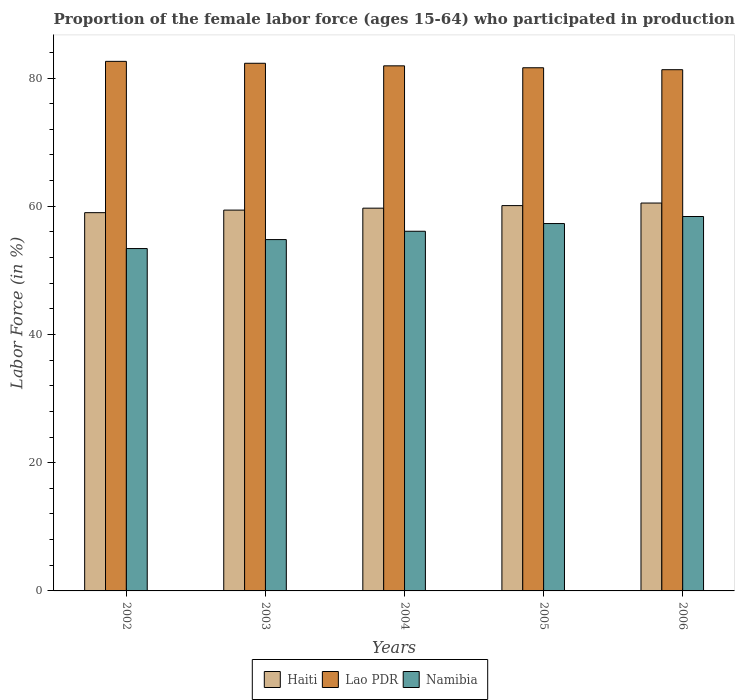How many groups of bars are there?
Offer a very short reply. 5. How many bars are there on the 5th tick from the right?
Give a very brief answer. 3. What is the label of the 1st group of bars from the left?
Give a very brief answer. 2002. What is the proportion of the female labor force who participated in production in Lao PDR in 2002?
Make the answer very short. 82.6. Across all years, what is the maximum proportion of the female labor force who participated in production in Namibia?
Give a very brief answer. 58.4. Across all years, what is the minimum proportion of the female labor force who participated in production in Haiti?
Offer a terse response. 59. What is the total proportion of the female labor force who participated in production in Haiti in the graph?
Your answer should be very brief. 298.7. What is the difference between the proportion of the female labor force who participated in production in Namibia in 2006 and the proportion of the female labor force who participated in production in Haiti in 2004?
Ensure brevity in your answer.  -1.3. What is the average proportion of the female labor force who participated in production in Haiti per year?
Offer a terse response. 59.74. In the year 2002, what is the difference between the proportion of the female labor force who participated in production in Lao PDR and proportion of the female labor force who participated in production in Haiti?
Ensure brevity in your answer.  23.6. What is the ratio of the proportion of the female labor force who participated in production in Haiti in 2002 to that in 2006?
Give a very brief answer. 0.98. Is the proportion of the female labor force who participated in production in Namibia in 2003 less than that in 2004?
Offer a terse response. Yes. Is the difference between the proportion of the female labor force who participated in production in Lao PDR in 2005 and 2006 greater than the difference between the proportion of the female labor force who participated in production in Haiti in 2005 and 2006?
Ensure brevity in your answer.  Yes. What is the difference between the highest and the second highest proportion of the female labor force who participated in production in Haiti?
Your answer should be compact. 0.4. Is the sum of the proportion of the female labor force who participated in production in Haiti in 2002 and 2005 greater than the maximum proportion of the female labor force who participated in production in Lao PDR across all years?
Keep it short and to the point. Yes. What does the 3rd bar from the left in 2002 represents?
Your answer should be compact. Namibia. What does the 1st bar from the right in 2005 represents?
Offer a very short reply. Namibia. Are all the bars in the graph horizontal?
Keep it short and to the point. No. How many years are there in the graph?
Your answer should be very brief. 5. Are the values on the major ticks of Y-axis written in scientific E-notation?
Ensure brevity in your answer.  No. Does the graph contain grids?
Your response must be concise. No. How many legend labels are there?
Give a very brief answer. 3. How are the legend labels stacked?
Make the answer very short. Horizontal. What is the title of the graph?
Provide a succinct answer. Proportion of the female labor force (ages 15-64) who participated in production. Does "Moldova" appear as one of the legend labels in the graph?
Ensure brevity in your answer.  No. What is the label or title of the X-axis?
Your response must be concise. Years. What is the Labor Force (in %) of Haiti in 2002?
Your answer should be very brief. 59. What is the Labor Force (in %) of Lao PDR in 2002?
Keep it short and to the point. 82.6. What is the Labor Force (in %) in Namibia in 2002?
Offer a terse response. 53.4. What is the Labor Force (in %) of Haiti in 2003?
Provide a succinct answer. 59.4. What is the Labor Force (in %) of Lao PDR in 2003?
Ensure brevity in your answer.  82.3. What is the Labor Force (in %) of Namibia in 2003?
Give a very brief answer. 54.8. What is the Labor Force (in %) of Haiti in 2004?
Your answer should be compact. 59.7. What is the Labor Force (in %) of Lao PDR in 2004?
Give a very brief answer. 81.9. What is the Labor Force (in %) of Namibia in 2004?
Ensure brevity in your answer.  56.1. What is the Labor Force (in %) in Haiti in 2005?
Provide a short and direct response. 60.1. What is the Labor Force (in %) in Lao PDR in 2005?
Your answer should be compact. 81.6. What is the Labor Force (in %) of Namibia in 2005?
Make the answer very short. 57.3. What is the Labor Force (in %) of Haiti in 2006?
Provide a short and direct response. 60.5. What is the Labor Force (in %) of Lao PDR in 2006?
Provide a short and direct response. 81.3. What is the Labor Force (in %) in Namibia in 2006?
Offer a terse response. 58.4. Across all years, what is the maximum Labor Force (in %) in Haiti?
Keep it short and to the point. 60.5. Across all years, what is the maximum Labor Force (in %) of Lao PDR?
Give a very brief answer. 82.6. Across all years, what is the maximum Labor Force (in %) in Namibia?
Offer a very short reply. 58.4. Across all years, what is the minimum Labor Force (in %) in Lao PDR?
Provide a short and direct response. 81.3. Across all years, what is the minimum Labor Force (in %) of Namibia?
Provide a short and direct response. 53.4. What is the total Labor Force (in %) of Haiti in the graph?
Offer a terse response. 298.7. What is the total Labor Force (in %) of Lao PDR in the graph?
Make the answer very short. 409.7. What is the total Labor Force (in %) of Namibia in the graph?
Make the answer very short. 280. What is the difference between the Labor Force (in %) of Lao PDR in 2002 and that in 2004?
Your response must be concise. 0.7. What is the difference between the Labor Force (in %) in Namibia in 2002 and that in 2004?
Keep it short and to the point. -2.7. What is the difference between the Labor Force (in %) of Haiti in 2002 and that in 2005?
Keep it short and to the point. -1.1. What is the difference between the Labor Force (in %) in Lao PDR in 2002 and that in 2005?
Offer a very short reply. 1. What is the difference between the Labor Force (in %) in Haiti in 2002 and that in 2006?
Provide a succinct answer. -1.5. What is the difference between the Labor Force (in %) in Haiti in 2003 and that in 2004?
Offer a terse response. -0.3. What is the difference between the Labor Force (in %) of Namibia in 2003 and that in 2004?
Offer a terse response. -1.3. What is the difference between the Labor Force (in %) in Haiti in 2003 and that in 2005?
Offer a very short reply. -0.7. What is the difference between the Labor Force (in %) of Namibia in 2003 and that in 2005?
Keep it short and to the point. -2.5. What is the difference between the Labor Force (in %) of Haiti in 2003 and that in 2006?
Offer a terse response. -1.1. What is the difference between the Labor Force (in %) in Namibia in 2003 and that in 2006?
Provide a short and direct response. -3.6. What is the difference between the Labor Force (in %) of Namibia in 2004 and that in 2005?
Give a very brief answer. -1.2. What is the difference between the Labor Force (in %) in Haiti in 2004 and that in 2006?
Offer a terse response. -0.8. What is the difference between the Labor Force (in %) in Lao PDR in 2004 and that in 2006?
Give a very brief answer. 0.6. What is the difference between the Labor Force (in %) in Namibia in 2004 and that in 2006?
Make the answer very short. -2.3. What is the difference between the Labor Force (in %) in Haiti in 2005 and that in 2006?
Your answer should be compact. -0.4. What is the difference between the Labor Force (in %) of Lao PDR in 2005 and that in 2006?
Ensure brevity in your answer.  0.3. What is the difference between the Labor Force (in %) of Namibia in 2005 and that in 2006?
Your answer should be very brief. -1.1. What is the difference between the Labor Force (in %) in Haiti in 2002 and the Labor Force (in %) in Lao PDR in 2003?
Ensure brevity in your answer.  -23.3. What is the difference between the Labor Force (in %) of Haiti in 2002 and the Labor Force (in %) of Namibia in 2003?
Keep it short and to the point. 4.2. What is the difference between the Labor Force (in %) of Lao PDR in 2002 and the Labor Force (in %) of Namibia in 2003?
Ensure brevity in your answer.  27.8. What is the difference between the Labor Force (in %) in Haiti in 2002 and the Labor Force (in %) in Lao PDR in 2004?
Provide a short and direct response. -22.9. What is the difference between the Labor Force (in %) in Haiti in 2002 and the Labor Force (in %) in Namibia in 2004?
Provide a short and direct response. 2.9. What is the difference between the Labor Force (in %) in Haiti in 2002 and the Labor Force (in %) in Lao PDR in 2005?
Ensure brevity in your answer.  -22.6. What is the difference between the Labor Force (in %) of Haiti in 2002 and the Labor Force (in %) of Namibia in 2005?
Make the answer very short. 1.7. What is the difference between the Labor Force (in %) in Lao PDR in 2002 and the Labor Force (in %) in Namibia in 2005?
Make the answer very short. 25.3. What is the difference between the Labor Force (in %) of Haiti in 2002 and the Labor Force (in %) of Lao PDR in 2006?
Offer a very short reply. -22.3. What is the difference between the Labor Force (in %) in Lao PDR in 2002 and the Labor Force (in %) in Namibia in 2006?
Provide a short and direct response. 24.2. What is the difference between the Labor Force (in %) of Haiti in 2003 and the Labor Force (in %) of Lao PDR in 2004?
Provide a succinct answer. -22.5. What is the difference between the Labor Force (in %) of Lao PDR in 2003 and the Labor Force (in %) of Namibia in 2004?
Your answer should be compact. 26.2. What is the difference between the Labor Force (in %) of Haiti in 2003 and the Labor Force (in %) of Lao PDR in 2005?
Keep it short and to the point. -22.2. What is the difference between the Labor Force (in %) of Haiti in 2003 and the Labor Force (in %) of Namibia in 2005?
Your response must be concise. 2.1. What is the difference between the Labor Force (in %) of Haiti in 2003 and the Labor Force (in %) of Lao PDR in 2006?
Keep it short and to the point. -21.9. What is the difference between the Labor Force (in %) in Haiti in 2003 and the Labor Force (in %) in Namibia in 2006?
Your response must be concise. 1. What is the difference between the Labor Force (in %) of Lao PDR in 2003 and the Labor Force (in %) of Namibia in 2006?
Keep it short and to the point. 23.9. What is the difference between the Labor Force (in %) in Haiti in 2004 and the Labor Force (in %) in Lao PDR in 2005?
Your answer should be compact. -21.9. What is the difference between the Labor Force (in %) of Haiti in 2004 and the Labor Force (in %) of Namibia in 2005?
Provide a succinct answer. 2.4. What is the difference between the Labor Force (in %) of Lao PDR in 2004 and the Labor Force (in %) of Namibia in 2005?
Make the answer very short. 24.6. What is the difference between the Labor Force (in %) in Haiti in 2004 and the Labor Force (in %) in Lao PDR in 2006?
Ensure brevity in your answer.  -21.6. What is the difference between the Labor Force (in %) in Haiti in 2004 and the Labor Force (in %) in Namibia in 2006?
Ensure brevity in your answer.  1.3. What is the difference between the Labor Force (in %) in Lao PDR in 2004 and the Labor Force (in %) in Namibia in 2006?
Offer a very short reply. 23.5. What is the difference between the Labor Force (in %) in Haiti in 2005 and the Labor Force (in %) in Lao PDR in 2006?
Give a very brief answer. -21.2. What is the difference between the Labor Force (in %) of Haiti in 2005 and the Labor Force (in %) of Namibia in 2006?
Offer a terse response. 1.7. What is the difference between the Labor Force (in %) of Lao PDR in 2005 and the Labor Force (in %) of Namibia in 2006?
Make the answer very short. 23.2. What is the average Labor Force (in %) of Haiti per year?
Offer a terse response. 59.74. What is the average Labor Force (in %) of Lao PDR per year?
Make the answer very short. 81.94. What is the average Labor Force (in %) of Namibia per year?
Your answer should be very brief. 56. In the year 2002, what is the difference between the Labor Force (in %) in Haiti and Labor Force (in %) in Lao PDR?
Give a very brief answer. -23.6. In the year 2002, what is the difference between the Labor Force (in %) in Lao PDR and Labor Force (in %) in Namibia?
Provide a short and direct response. 29.2. In the year 2003, what is the difference between the Labor Force (in %) of Haiti and Labor Force (in %) of Lao PDR?
Your answer should be very brief. -22.9. In the year 2004, what is the difference between the Labor Force (in %) in Haiti and Labor Force (in %) in Lao PDR?
Make the answer very short. -22.2. In the year 2004, what is the difference between the Labor Force (in %) of Lao PDR and Labor Force (in %) of Namibia?
Your answer should be compact. 25.8. In the year 2005, what is the difference between the Labor Force (in %) in Haiti and Labor Force (in %) in Lao PDR?
Provide a short and direct response. -21.5. In the year 2005, what is the difference between the Labor Force (in %) of Lao PDR and Labor Force (in %) of Namibia?
Give a very brief answer. 24.3. In the year 2006, what is the difference between the Labor Force (in %) in Haiti and Labor Force (in %) in Lao PDR?
Keep it short and to the point. -20.8. In the year 2006, what is the difference between the Labor Force (in %) of Lao PDR and Labor Force (in %) of Namibia?
Provide a short and direct response. 22.9. What is the ratio of the Labor Force (in %) of Haiti in 2002 to that in 2003?
Offer a terse response. 0.99. What is the ratio of the Labor Force (in %) in Namibia in 2002 to that in 2003?
Provide a succinct answer. 0.97. What is the ratio of the Labor Force (in %) in Haiti in 2002 to that in 2004?
Your answer should be very brief. 0.99. What is the ratio of the Labor Force (in %) in Lao PDR in 2002 to that in 2004?
Provide a short and direct response. 1.01. What is the ratio of the Labor Force (in %) in Namibia in 2002 to that in 2004?
Provide a short and direct response. 0.95. What is the ratio of the Labor Force (in %) of Haiti in 2002 to that in 2005?
Your answer should be very brief. 0.98. What is the ratio of the Labor Force (in %) in Lao PDR in 2002 to that in 2005?
Give a very brief answer. 1.01. What is the ratio of the Labor Force (in %) of Namibia in 2002 to that in 2005?
Keep it short and to the point. 0.93. What is the ratio of the Labor Force (in %) in Haiti in 2002 to that in 2006?
Give a very brief answer. 0.98. What is the ratio of the Labor Force (in %) in Namibia in 2002 to that in 2006?
Offer a very short reply. 0.91. What is the ratio of the Labor Force (in %) in Lao PDR in 2003 to that in 2004?
Give a very brief answer. 1. What is the ratio of the Labor Force (in %) of Namibia in 2003 to that in 2004?
Provide a succinct answer. 0.98. What is the ratio of the Labor Force (in %) in Haiti in 2003 to that in 2005?
Ensure brevity in your answer.  0.99. What is the ratio of the Labor Force (in %) in Lao PDR in 2003 to that in 2005?
Keep it short and to the point. 1.01. What is the ratio of the Labor Force (in %) in Namibia in 2003 to that in 2005?
Keep it short and to the point. 0.96. What is the ratio of the Labor Force (in %) in Haiti in 2003 to that in 2006?
Keep it short and to the point. 0.98. What is the ratio of the Labor Force (in %) of Lao PDR in 2003 to that in 2006?
Offer a very short reply. 1.01. What is the ratio of the Labor Force (in %) in Namibia in 2003 to that in 2006?
Make the answer very short. 0.94. What is the ratio of the Labor Force (in %) of Namibia in 2004 to that in 2005?
Your response must be concise. 0.98. What is the ratio of the Labor Force (in %) in Haiti in 2004 to that in 2006?
Provide a succinct answer. 0.99. What is the ratio of the Labor Force (in %) in Lao PDR in 2004 to that in 2006?
Offer a terse response. 1.01. What is the ratio of the Labor Force (in %) in Namibia in 2004 to that in 2006?
Offer a terse response. 0.96. What is the ratio of the Labor Force (in %) in Namibia in 2005 to that in 2006?
Provide a short and direct response. 0.98. What is the difference between the highest and the second highest Labor Force (in %) in Haiti?
Your answer should be compact. 0.4. What is the difference between the highest and the second highest Labor Force (in %) in Namibia?
Your answer should be very brief. 1.1. What is the difference between the highest and the lowest Labor Force (in %) of Lao PDR?
Ensure brevity in your answer.  1.3. 